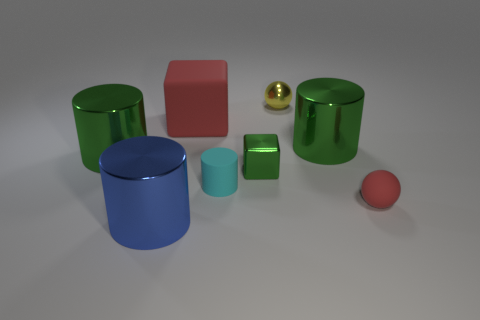Add 1 small blue metal cylinders. How many objects exist? 9 Subtract all spheres. How many objects are left? 6 Subtract 0 gray cubes. How many objects are left? 8 Subtract all red spheres. Subtract all tiny red spheres. How many objects are left? 6 Add 1 big blue metal objects. How many big blue metal objects are left? 2 Add 5 tiny rubber cubes. How many tiny rubber cubes exist? 5 